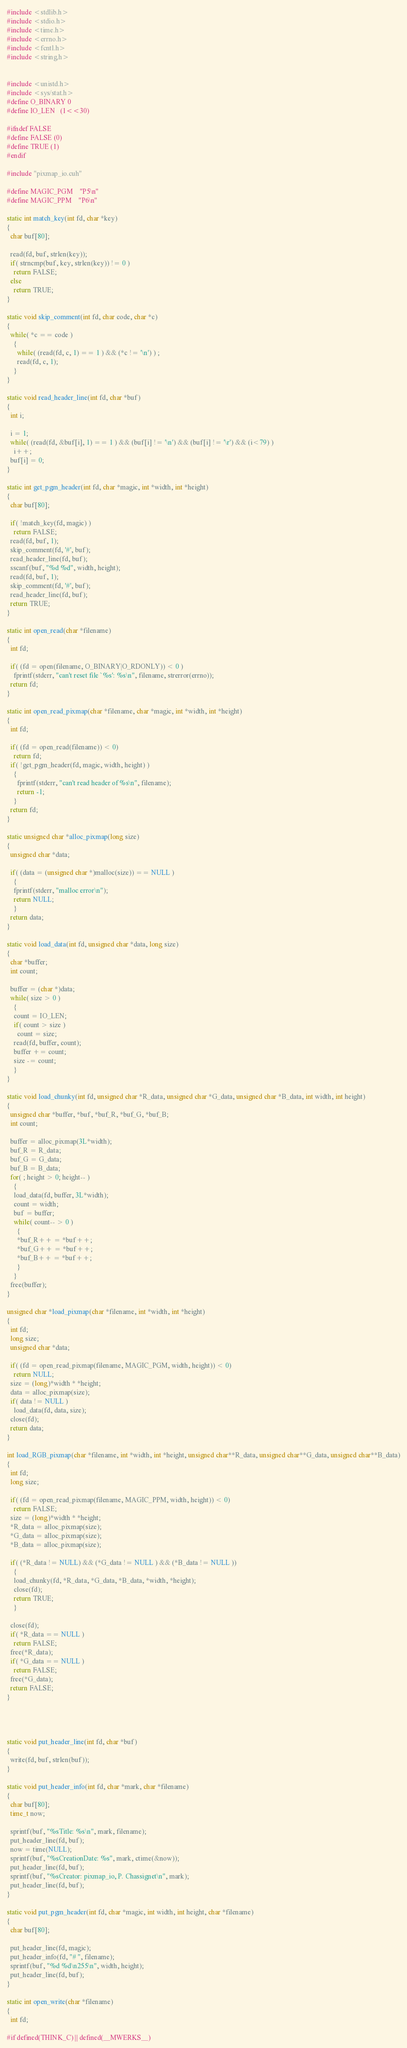<code> <loc_0><loc_0><loc_500><loc_500><_Cuda_>#include <stdlib.h>
#include <stdio.h>
#include <time.h>
#include <errno.h>
#include <fcntl.h>
#include <string.h>


#include <unistd.h>
#include <sys/stat.h>
#define O_BINARY 0
#define IO_LEN	(1<<30)	

#ifndef FALSE
#define FALSE (0)
#define TRUE (1)
#endif

#include "pixmap_io.cuh"

#define MAGIC_PGM	"P5\n"
#define MAGIC_PPM	"P6\n"

static int match_key(int fd, char *key)
{
  char buf[80];

  read(fd, buf, strlen(key));
  if( strncmp(buf, key, strlen(key)) != 0 )
    return FALSE;
  else
    return TRUE;
}

static void skip_comment(int fd, char code, char *c)
{
  while( *c == code )
    {
      while( (read(fd, c, 1) == 1 ) && (*c != '\n') ) ;
      read(fd, c, 1);
    }
}

static void read_header_line(int fd, char *buf)
{
  int i;

  i = 1;
  while( (read(fd, &buf[i], 1) == 1 ) && (buf[i] != '\n') && (buf[i] != '\r') && (i<79) )
    i++;
  buf[i] = 0;
}

static int get_pgm_header(int fd, char *magic, int *width, int *height)
{
  char buf[80];

  if( !match_key(fd, magic) )
    return FALSE;
  read(fd, buf, 1);
  skip_comment(fd, '#', buf);
  read_header_line(fd, buf);
  sscanf(buf, "%d %d", width, height);
  read(fd, buf, 1);
  skip_comment(fd, '#', buf);
  read_header_line(fd, buf);
  return TRUE;
}

static int open_read(char *filename)
{
  int fd;

  if( (fd = open(filename, O_BINARY|O_RDONLY)) < 0 )
    fprintf(stderr, "can't reset file `%s': %s\n", filename, strerror(errno));
  return fd;
}

static int open_read_pixmap(char *filename, char *magic, int *width, int *height)
{
  int fd;

  if( (fd = open_read(filename)) < 0)
    return fd;
  if( !get_pgm_header(fd, magic, width, height) )
    {
      fprintf(stderr, "can't read header of %s\n", filename);
      return -1;
    }
  return fd;
}

static unsigned char *alloc_pixmap(long size)
{
  unsigned char *data;

  if( (data = (unsigned char *)malloc(size)) == NULL )
    {
    fprintf(stderr, "malloc error\n");
    return NULL;
    }
  return data;
}

static void load_data(int fd, unsigned char *data, long size)
{
  char *buffer;
  int count;

  buffer = (char *)data;
  while( size > 0 )
    {
    count = IO_LEN;
    if( count > size )
      count = size;
    read(fd, buffer, count);
    buffer += count;
    size -= count;
    }
}

static void load_chunky(int fd, unsigned char *R_data, unsigned char *G_data, unsigned char *B_data, int width, int height)
{
  unsigned char *buffer, *buf, *buf_R, *buf_G, *buf_B;
  int count;

  buffer = alloc_pixmap(3L*width);
  buf_R = R_data;
  buf_G = G_data;
  buf_B = B_data;
  for( ; height > 0; height-- )
    {
    load_data(fd, buffer, 3L*width);
    count = width;
    buf = buffer;
    while( count-- > 0 )
      {
      *buf_R++ = *buf++;
      *buf_G++ = *buf++;
      *buf_B++ = *buf++;
      }
    }
  free(buffer);
}

unsigned char *load_pixmap(char *filename, int *width, int *height)
{
  int fd;
  long size;
  unsigned char *data;

  if( (fd = open_read_pixmap(filename, MAGIC_PGM, width, height)) < 0)
    return NULL;
  size = (long)*width * *height;
  data = alloc_pixmap(size);
  if( data != NULL )
    load_data(fd, data, size);
  close(fd);
  return data;
}

int load_RGB_pixmap(char *filename, int *width, int *height, unsigned char**R_data, unsigned char**G_data, unsigned char**B_data)
{
  int fd;
  long size;

  if( (fd = open_read_pixmap(filename, MAGIC_PPM, width, height)) < 0)
    return FALSE;
  size = (long)*width * *height;
  *R_data = alloc_pixmap(size);
  *G_data = alloc_pixmap(size);
  *B_data = alloc_pixmap(size);
  
  if( (*R_data != NULL) && (*G_data != NULL ) && (*B_data != NULL ))
    {
    load_chunky(fd, *R_data, *G_data, *B_data, *width, *height);
    close(fd);
    return TRUE;
    }

  close(fd);
  if( *R_data == NULL )
    return FALSE;
  free(*R_data);
  if( *G_data == NULL )
    return FALSE;
  free(*G_data);
  return FALSE;
}




static void put_header_line(int fd, char *buf)
{
  write(fd, buf, strlen(buf));
}

static void put_header_info(int fd, char *mark, char *filename)
{
  char buf[80];
  time_t now;

  sprintf(buf, "%sTitle: %s\n", mark, filename);
  put_header_line(fd, buf);
  now = time(NULL);
  sprintf(buf, "%sCreationDate: %s", mark, ctime(&now));
  put_header_line(fd, buf);
  sprintf(buf, "%sCreator: pixmap_io, P. Chassignet\n", mark);
  put_header_line(fd, buf);
}

static void put_pgm_header(int fd, char *magic, int width, int height, char *filename)
{
  char buf[80];

  put_header_line(fd, magic);
  put_header_info(fd, "# ", filename);
  sprintf(buf, "%d %d\n255\n", width, height);
  put_header_line(fd, buf);
}

static int open_write(char *filename)
{
  int fd;

#if defined(THINK_C) || defined(__MWERKS__)</code> 